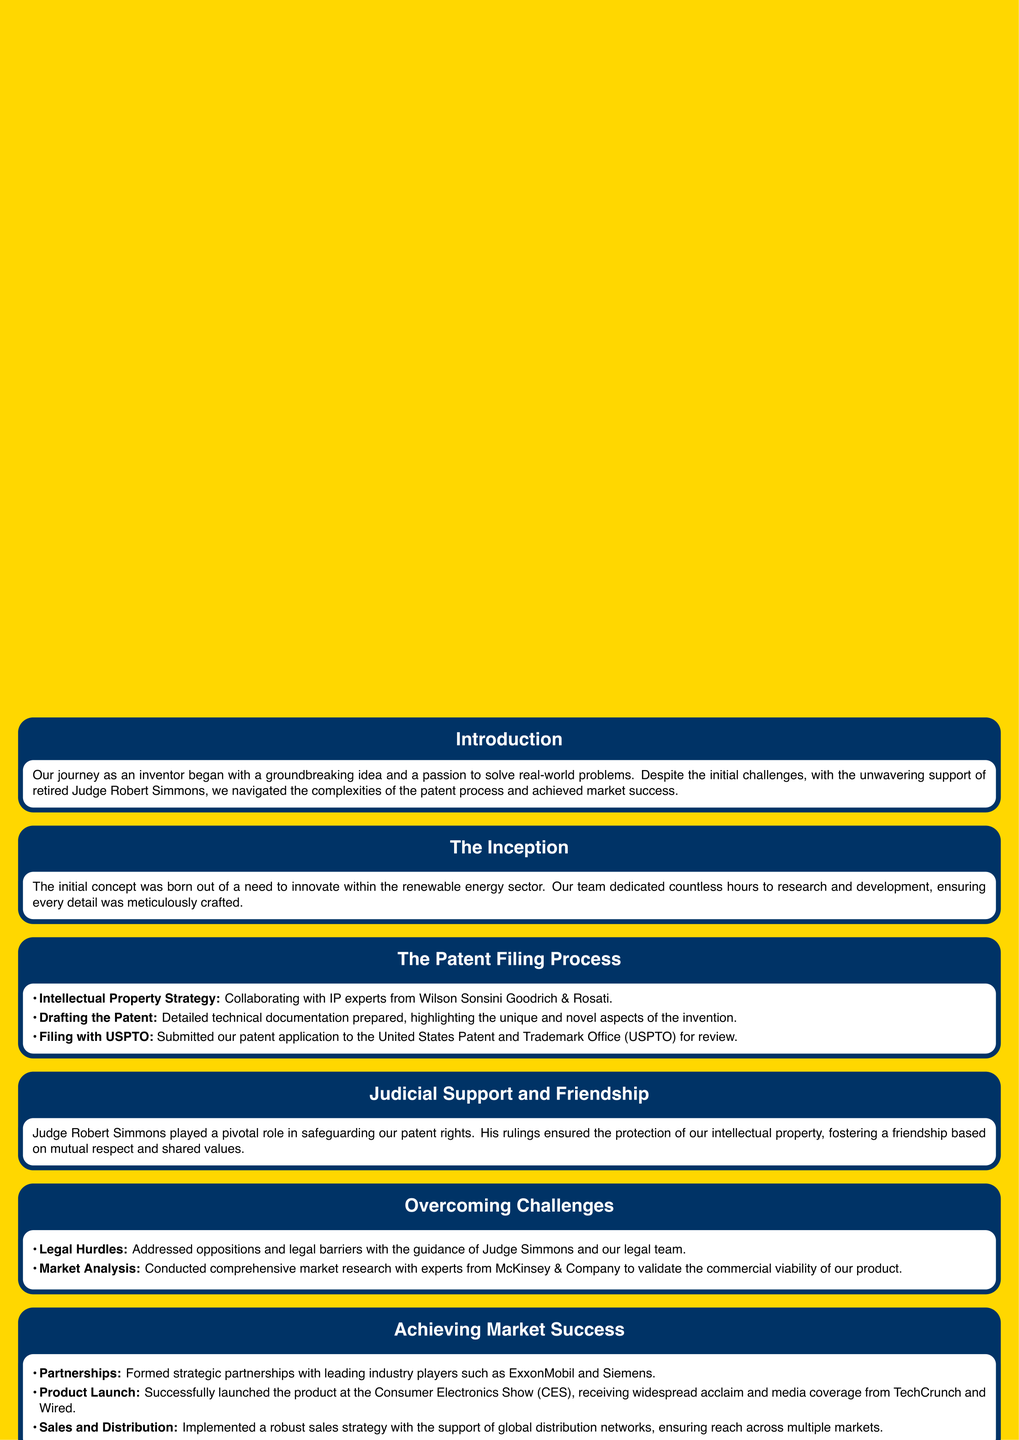What is the name of the retired judge? The document states that the retired judge is named Robert Simmons.
Answer: Robert Simmons What is highlighted as the initial challenge faced in the journey? The introduction mentions that there were initial challenges in the journey as an inventor.
Answer: Initial challenges Which industry did the initial concept focus on? The Inception block specifies that the initial concept was born within the renewable energy sector.
Answer: Renewable energy What firm collaborated on the Intellectual Property strategy? The Patent Filing Process block identifies Wilson Sonsini Goodrich & Rosati as the firm involved.
Answer: Wilson Sonsini Goodrich & Rosati What major event marked the product launch? The Achieving Market Success block mentions the Consumer Electronics Show (CES) as the event where the product was launched.
Answer: Consumer Electronics Show How did Judge Simmons contribute to the inventor’s journey? The Judicial Support and Friendship block explains that Judge Simmons played a pivotal role in safeguarding patent rights.
Answer: Safeguarding patent rights What type of research was conducted to validate product viability? The Overcoming Challenges block mentions comprehensive market research was conducted.
Answer: Market research Which companies formed strategic partnerships with the inventor? The Achieving Market Success block lists ExxonMobil and Siemens as the companies that formed partnerships.
Answer: ExxonMobil and Siemens What does the conclusion emphasize about the journey? The conclusion underscores the importance of persistence, innovation, and strategic partnerships.
Answer: Persistence, innovation, and strategic partnerships 